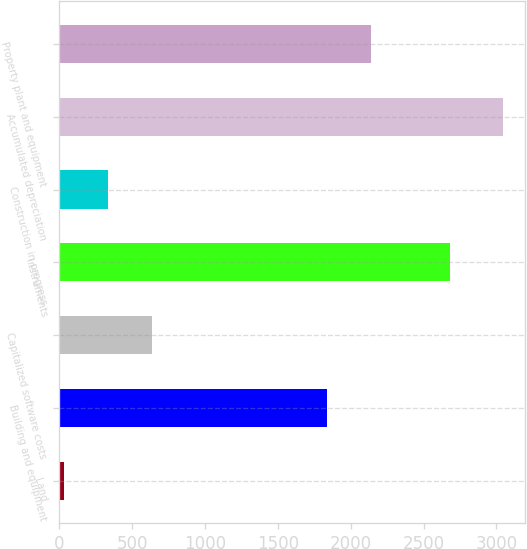Convert chart to OTSL. <chart><loc_0><loc_0><loc_500><loc_500><bar_chart><fcel>Land<fcel>Building and equipment<fcel>Capitalized software costs<fcel>Instruments<fcel>Construction in progress<fcel>Accumulated depreciation<fcel>Property plant and equipment<nl><fcel>29<fcel>1838.5<fcel>632.22<fcel>2683.9<fcel>330.61<fcel>3045.1<fcel>2140.11<nl></chart> 